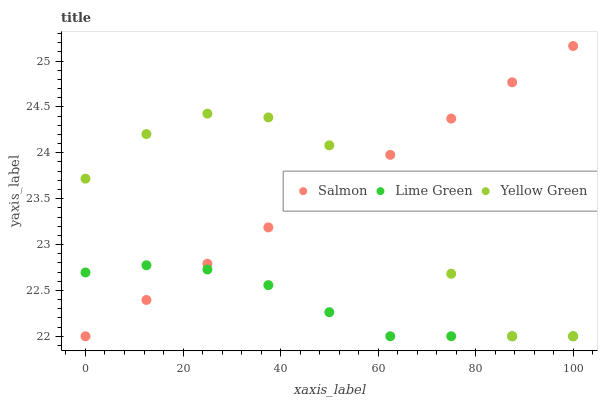Does Lime Green have the minimum area under the curve?
Answer yes or no. Yes. Does Salmon have the maximum area under the curve?
Answer yes or no. Yes. Does Yellow Green have the minimum area under the curve?
Answer yes or no. No. Does Yellow Green have the maximum area under the curve?
Answer yes or no. No. Is Salmon the smoothest?
Answer yes or no. Yes. Is Yellow Green the roughest?
Answer yes or no. Yes. Is Yellow Green the smoothest?
Answer yes or no. No. Is Salmon the roughest?
Answer yes or no. No. Does Lime Green have the lowest value?
Answer yes or no. Yes. Does Salmon have the highest value?
Answer yes or no. Yes. Does Yellow Green have the highest value?
Answer yes or no. No. Does Yellow Green intersect Salmon?
Answer yes or no. Yes. Is Yellow Green less than Salmon?
Answer yes or no. No. Is Yellow Green greater than Salmon?
Answer yes or no. No. 